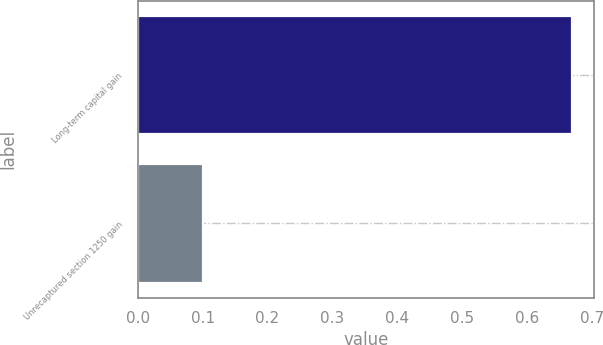<chart> <loc_0><loc_0><loc_500><loc_500><bar_chart><fcel>Long-term capital gain<fcel>Unrecaptured section 1250 gain<nl><fcel>0.67<fcel>0.1<nl></chart> 